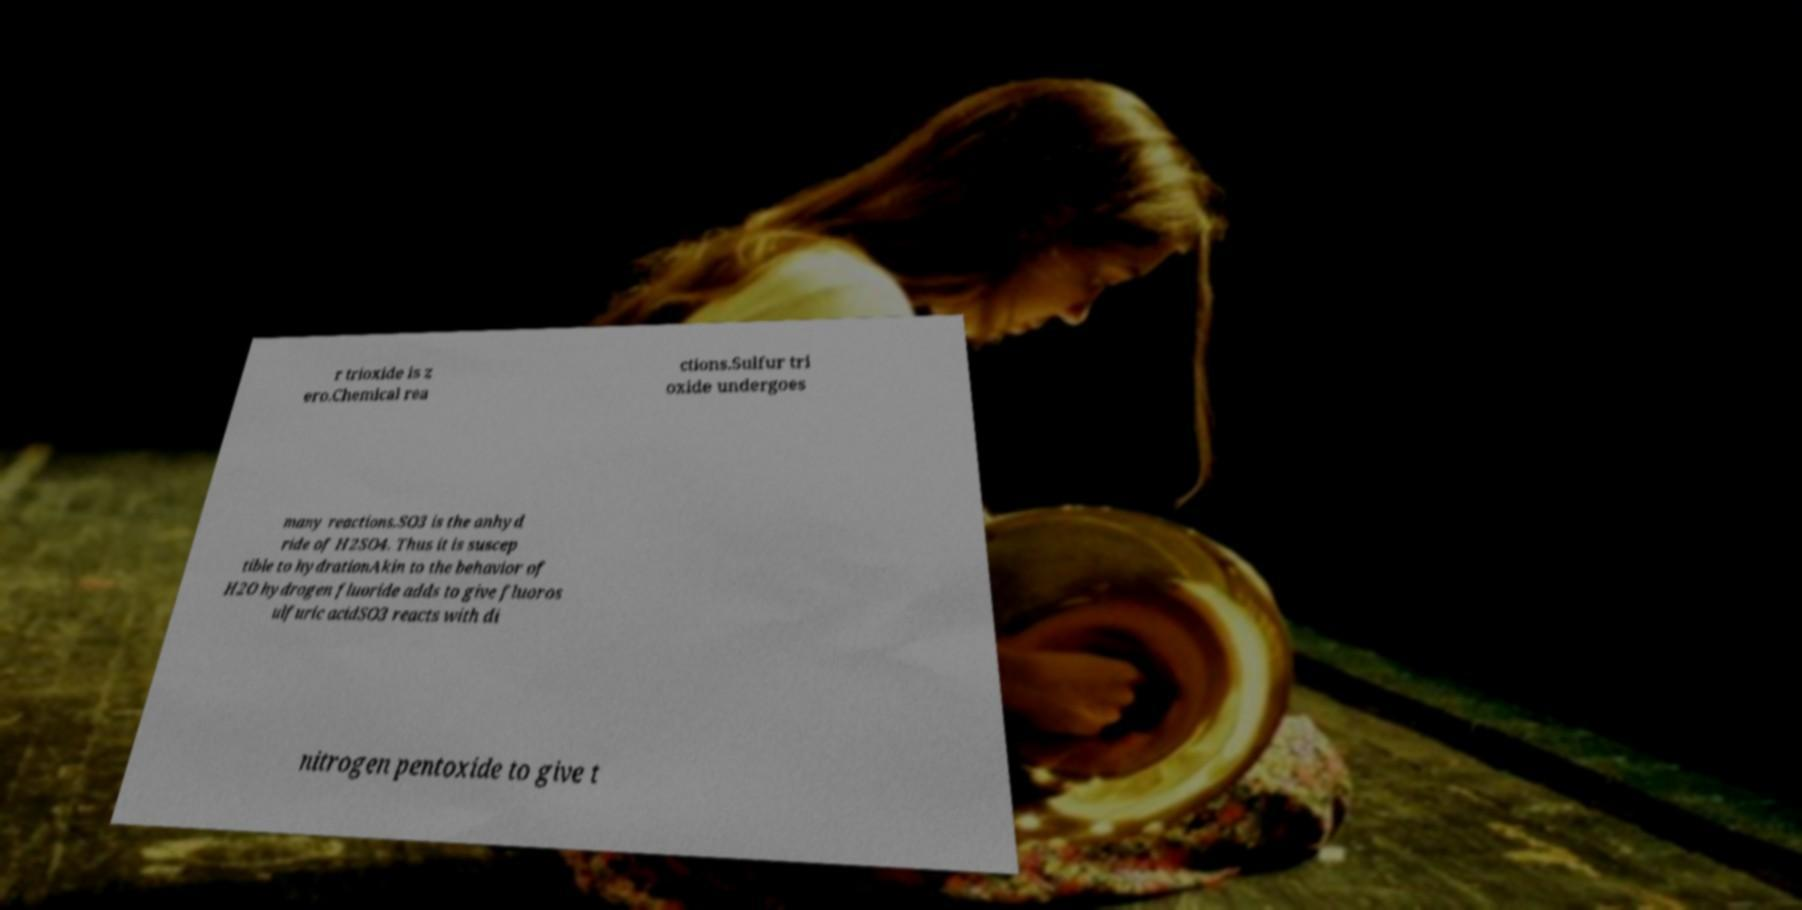For documentation purposes, I need the text within this image transcribed. Could you provide that? r trioxide is z ero.Chemical rea ctions.Sulfur tri oxide undergoes many reactions.SO3 is the anhyd ride of H2SO4. Thus it is suscep tible to hydrationAkin to the behavior of H2O hydrogen fluoride adds to give fluoros ulfuric acidSO3 reacts with di nitrogen pentoxide to give t 